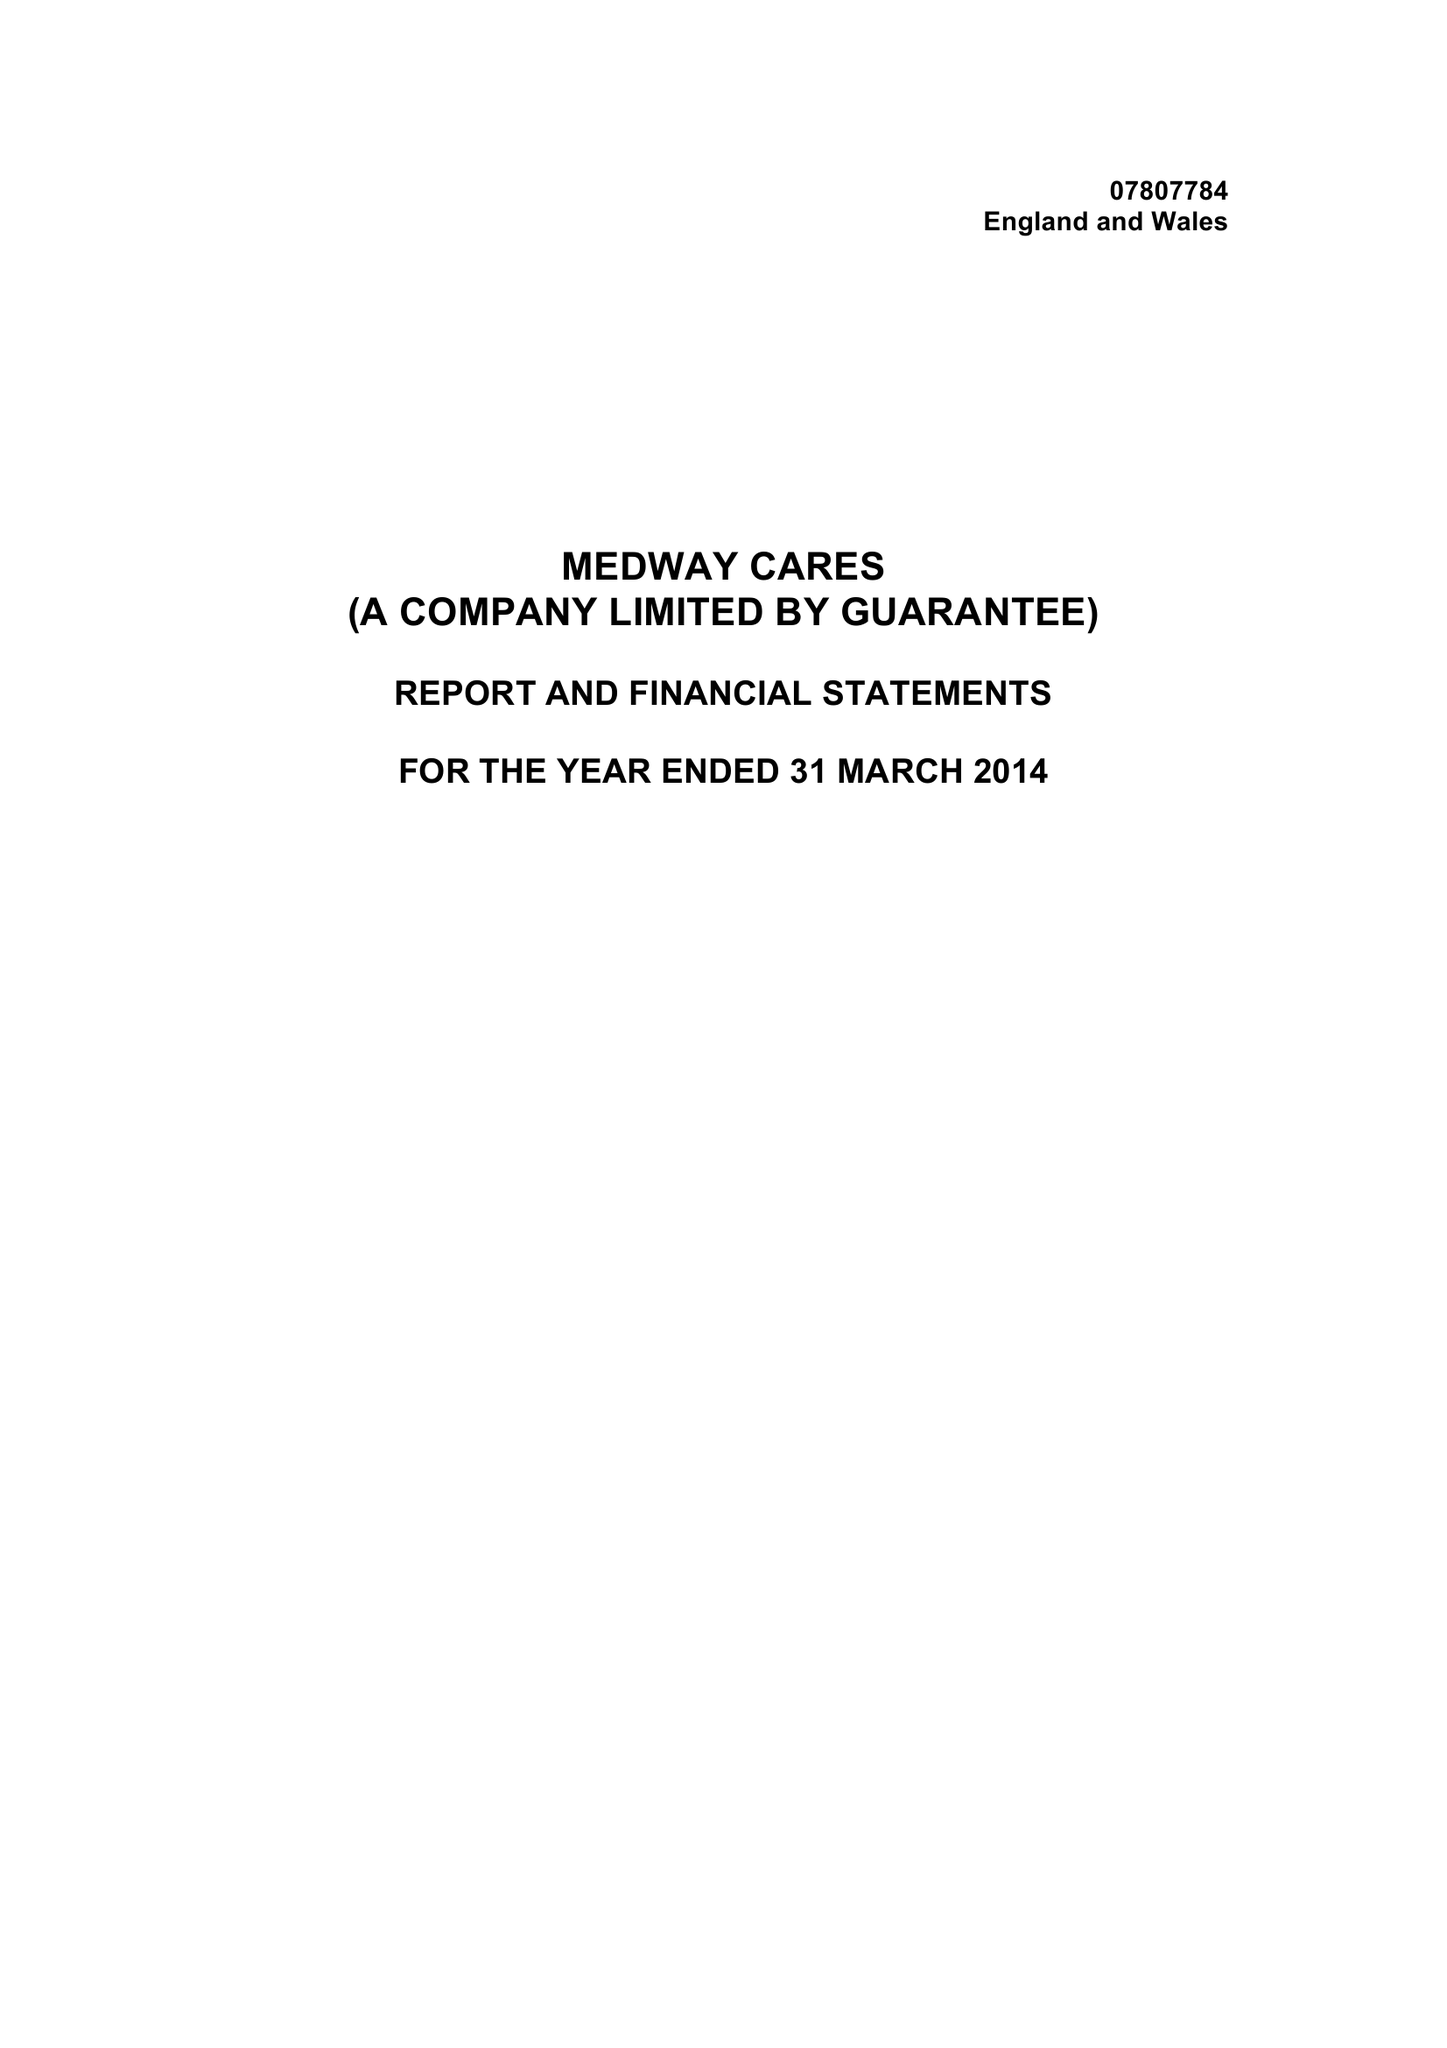What is the value for the spending_annually_in_british_pounds?
Answer the question using a single word or phrase. 6403.00 